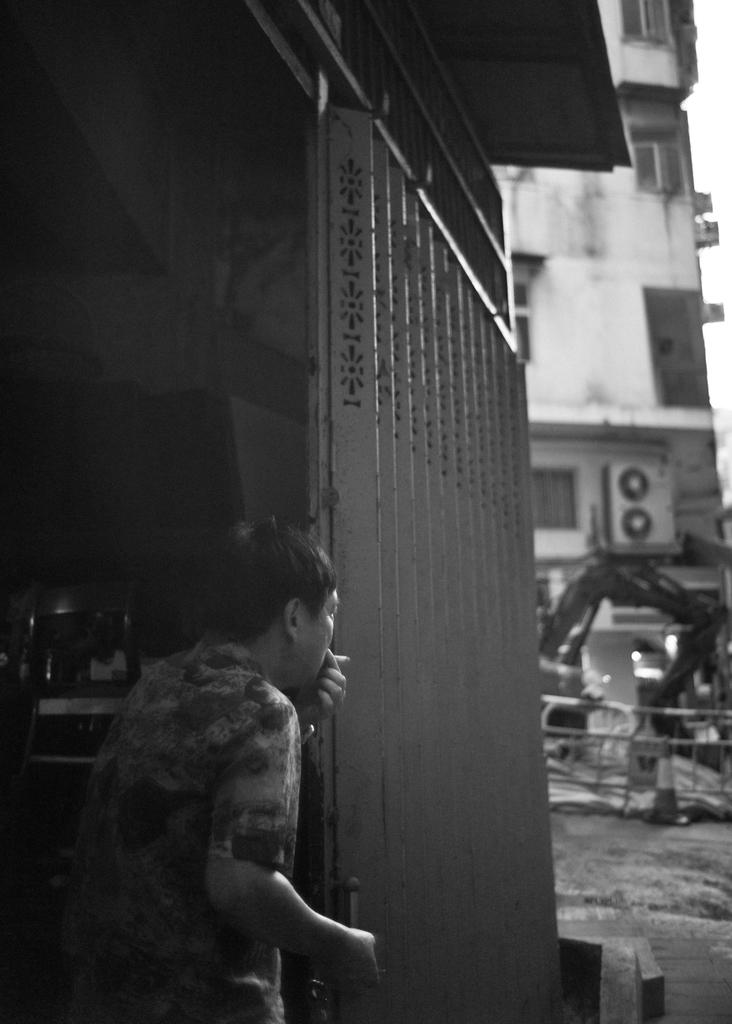Who or what is present in the image? There is a person in the image. What is the person wearing? The person is wearing a dress. What can be seen in the background of the image? There are buildings, a railing, and the sky visible in the background of the image. What is the color scheme of the image? The image is black and white. What type of noise can be heard coming from the playground in the image? There is no playground present in the image, so it is not possible to determine what, if any, noise might be heard. 